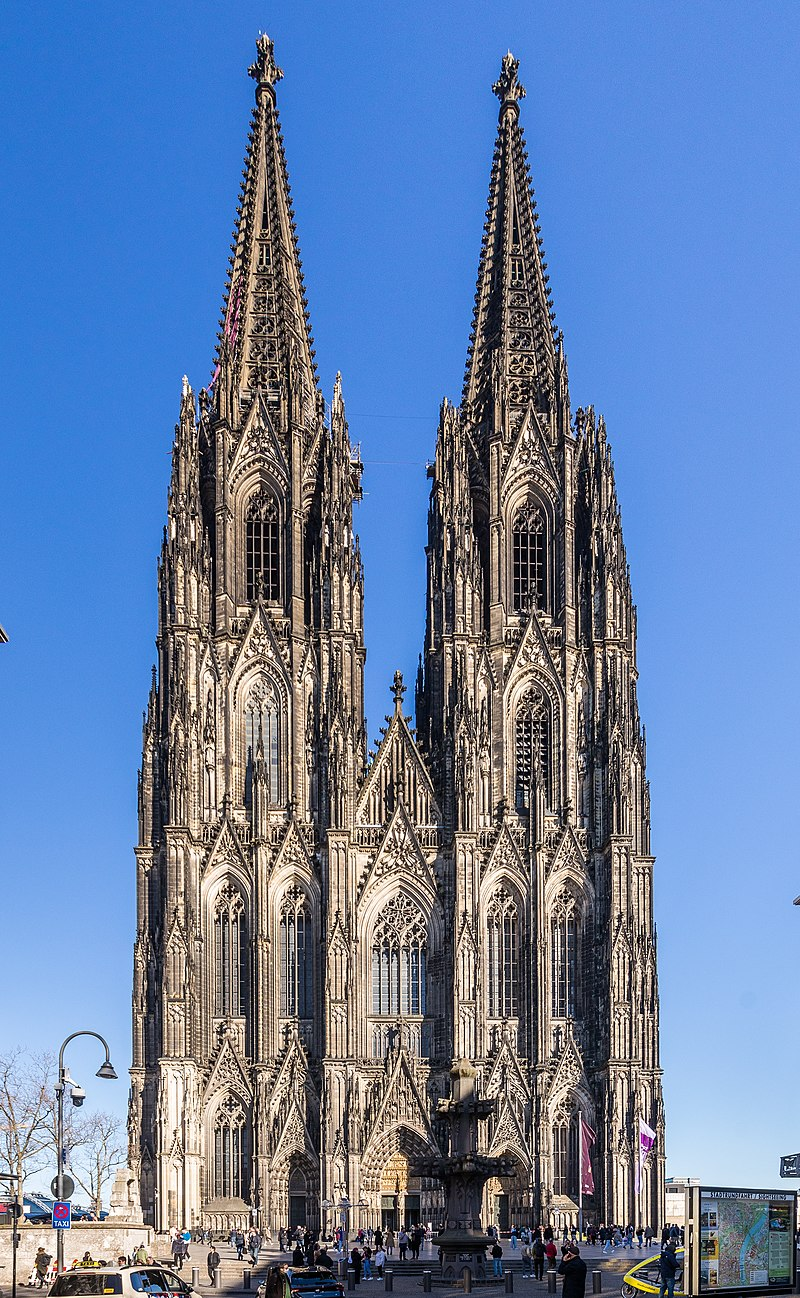Explain the visual content of the image in great detail. The image depicts the Cologne Cathedral, an iconic Gothic masterpiece located in Cologne, Germany. This historic edifice is famed for its towering twin spires, which dominate the skyline at an impressive height. The detailed stonework and flying buttresses exemplify classic Gothic architecture. The cathedral's facade is bathed in sunlight, which accentuates its ornate carvings and the intricate details of the stained glass windows visible from this front view. Pedestrians roam the plaza, offering a lively contrast to the solemn grandeur of the cathedral. Additionally, the clear blue sky serves as a serene backdrop, emphasizing the structure's height and elegance. The preservation of this UNESCO World Heritage Site reflects its cultural and architectural significance, enticing visitors from around the globe. 